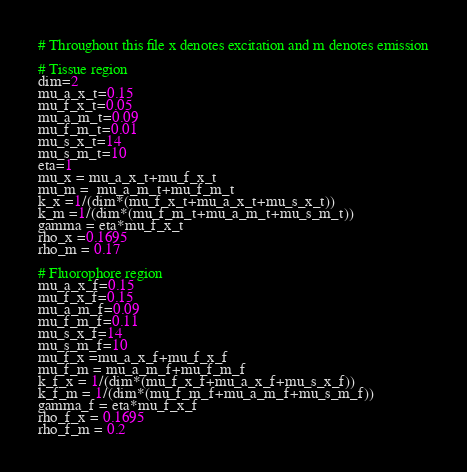<code> <loc_0><loc_0><loc_500><loc_500><_Python_># Throughout this file x denotes excitation and m denotes emission

# Tissue region
dim=2
mu_a_x_t=0.15
mu_f_x_t=0.05
mu_a_m_t=0.09
mu_f_m_t=0.01
mu_s_x_t=14
mu_s_m_t=10
eta=1
mu_x = mu_a_x_t+mu_f_x_t
mu_m =  mu_a_m_t+mu_f_m_t
k_x =1/(dim*(mu_f_x_t+mu_a_x_t+mu_s_x_t))
k_m =1/(dim*(mu_f_m_t+mu_a_m_t+mu_s_m_t))
gamma = eta*mu_f_x_t
rho_x =0.1695
rho_m = 0.17

# Fluorophore region
mu_a_x_f=0.15
mu_f_x_f=0.15
mu_a_m_f=0.09
mu_f_m_f=0.11
mu_s_x_f=14
mu_s_m_f=10
mu_f_x =mu_a_x_f+mu_f_x_f
mu_f_m = mu_a_m_f+mu_f_m_f
k_f_x = 1/(dim*(mu_f_x_f+mu_a_x_f+mu_s_x_f))
k_f_m = 1/(dim*(mu_f_m_f+mu_a_m_f+mu_s_m_f))
gamma_f = eta*mu_f_x_f 
rho_f_x = 0.1695
rho_f_m = 0.2</code> 